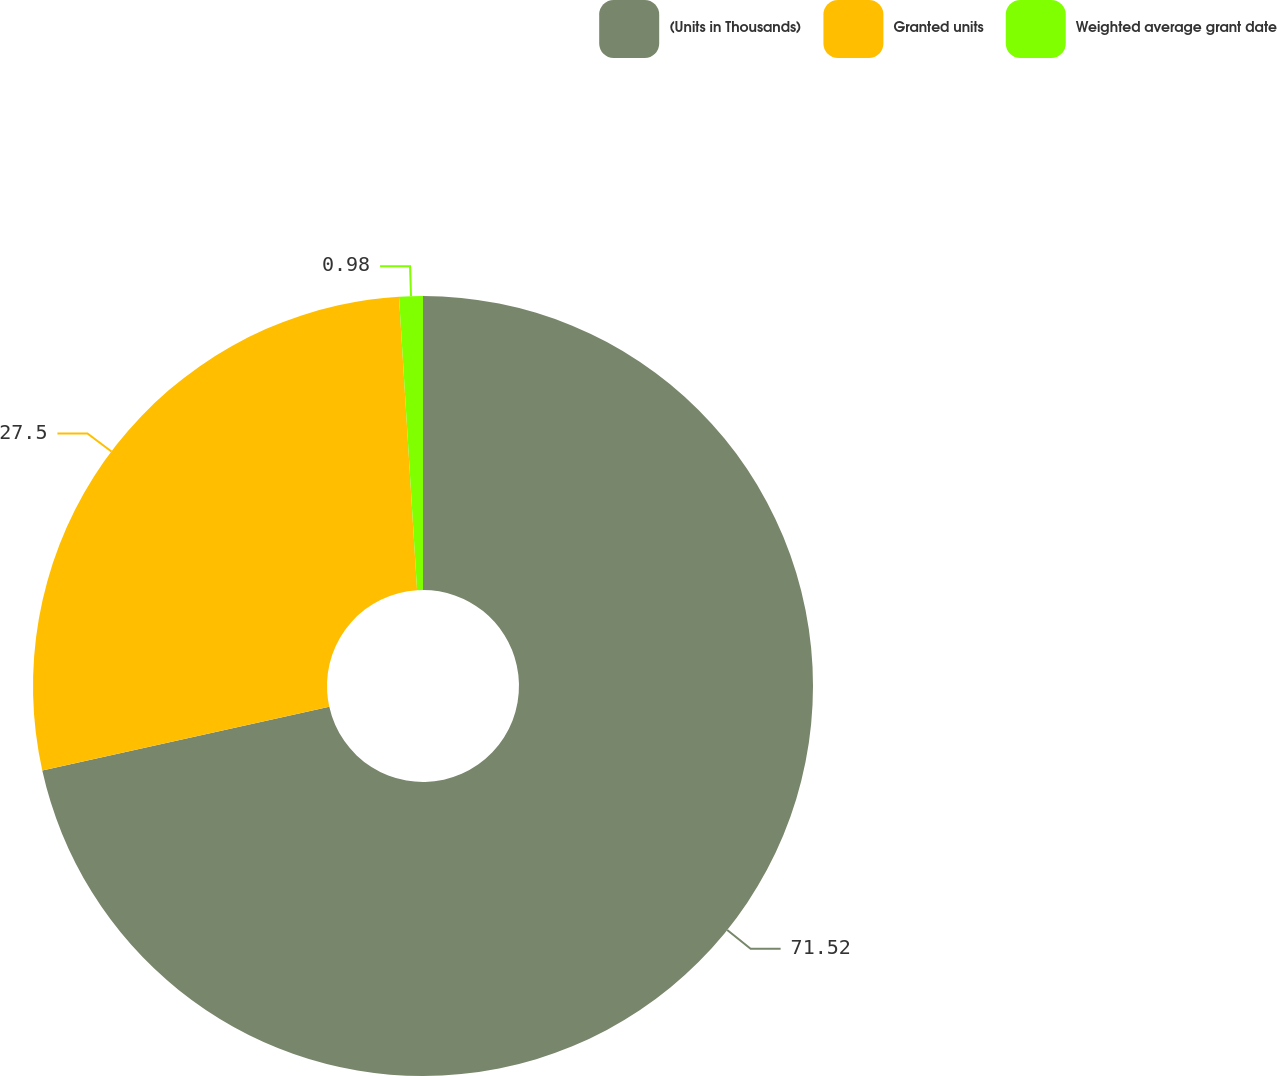<chart> <loc_0><loc_0><loc_500><loc_500><pie_chart><fcel>(Units in Thousands)<fcel>Granted units<fcel>Weighted average grant date<nl><fcel>71.52%<fcel>27.5%<fcel>0.98%<nl></chart> 